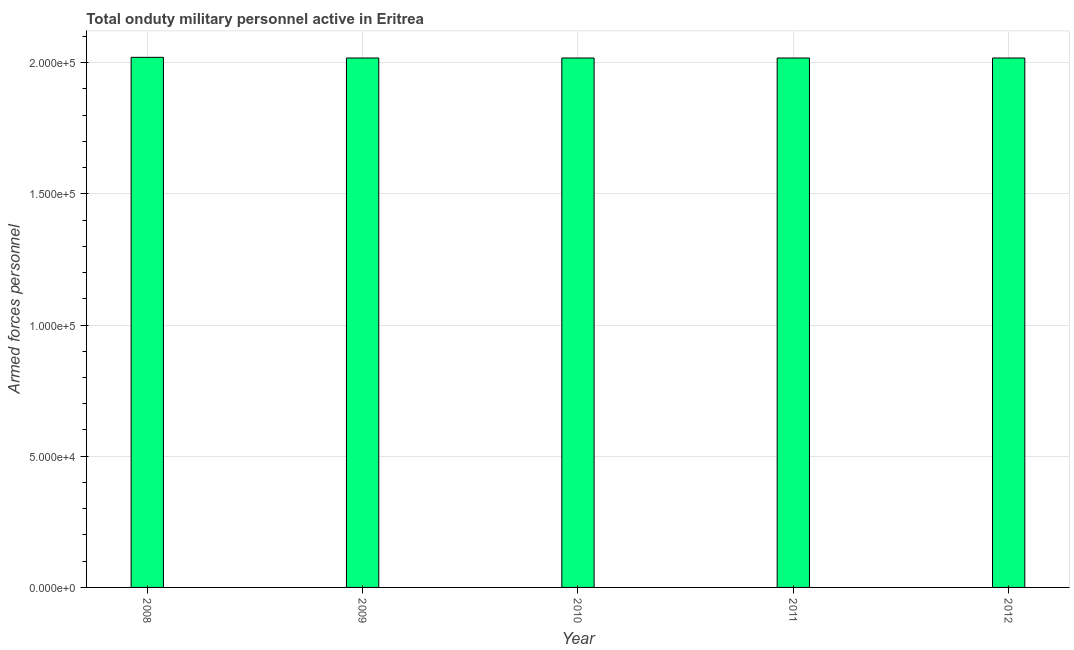Does the graph contain any zero values?
Offer a terse response. No. Does the graph contain grids?
Offer a terse response. Yes. What is the title of the graph?
Your answer should be very brief. Total onduty military personnel active in Eritrea. What is the label or title of the X-axis?
Provide a short and direct response. Year. What is the label or title of the Y-axis?
Your response must be concise. Armed forces personnel. What is the number of armed forces personnel in 2011?
Your response must be concise. 2.02e+05. Across all years, what is the maximum number of armed forces personnel?
Your answer should be compact. 2.02e+05. Across all years, what is the minimum number of armed forces personnel?
Offer a very short reply. 2.02e+05. In which year was the number of armed forces personnel maximum?
Make the answer very short. 2008. What is the sum of the number of armed forces personnel?
Make the answer very short. 1.01e+06. What is the difference between the number of armed forces personnel in 2008 and 2012?
Provide a succinct answer. 250. What is the average number of armed forces personnel per year?
Offer a terse response. 2.02e+05. What is the median number of armed forces personnel?
Provide a short and direct response. 2.02e+05. Do a majority of the years between 2008 and 2010 (inclusive) have number of armed forces personnel greater than 140000 ?
Make the answer very short. Yes. What is the ratio of the number of armed forces personnel in 2008 to that in 2012?
Your response must be concise. 1. Is the number of armed forces personnel in 2010 less than that in 2011?
Give a very brief answer. No. What is the difference between the highest and the second highest number of armed forces personnel?
Your response must be concise. 250. Is the sum of the number of armed forces personnel in 2011 and 2012 greater than the maximum number of armed forces personnel across all years?
Ensure brevity in your answer.  Yes. What is the difference between the highest and the lowest number of armed forces personnel?
Give a very brief answer. 250. What is the difference between two consecutive major ticks on the Y-axis?
Make the answer very short. 5.00e+04. Are the values on the major ticks of Y-axis written in scientific E-notation?
Make the answer very short. Yes. What is the Armed forces personnel in 2008?
Offer a very short reply. 2.02e+05. What is the Armed forces personnel in 2009?
Give a very brief answer. 2.02e+05. What is the Armed forces personnel of 2010?
Make the answer very short. 2.02e+05. What is the Armed forces personnel in 2011?
Provide a succinct answer. 2.02e+05. What is the Armed forces personnel in 2012?
Offer a terse response. 2.02e+05. What is the difference between the Armed forces personnel in 2008 and 2009?
Ensure brevity in your answer.  250. What is the difference between the Armed forces personnel in 2008 and 2010?
Ensure brevity in your answer.  250. What is the difference between the Armed forces personnel in 2008 and 2011?
Your answer should be very brief. 250. What is the difference between the Armed forces personnel in 2008 and 2012?
Your response must be concise. 250. What is the difference between the Armed forces personnel in 2010 and 2012?
Keep it short and to the point. 0. What is the ratio of the Armed forces personnel in 2008 to that in 2010?
Keep it short and to the point. 1. What is the ratio of the Armed forces personnel in 2008 to that in 2012?
Your response must be concise. 1. What is the ratio of the Armed forces personnel in 2009 to that in 2010?
Your answer should be very brief. 1. What is the ratio of the Armed forces personnel in 2009 to that in 2011?
Keep it short and to the point. 1. What is the ratio of the Armed forces personnel in 2010 to that in 2011?
Provide a succinct answer. 1. What is the ratio of the Armed forces personnel in 2010 to that in 2012?
Your response must be concise. 1. 